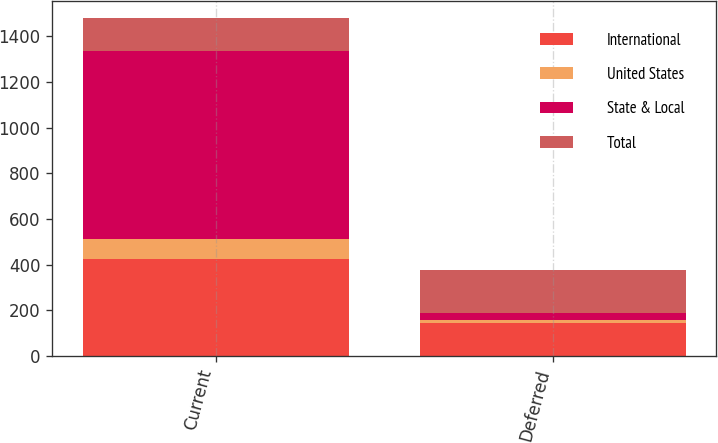<chart> <loc_0><loc_0><loc_500><loc_500><stacked_bar_chart><ecel><fcel>Current<fcel>Deferred<nl><fcel>International<fcel>426<fcel>145<nl><fcel>United States<fcel>84<fcel>11<nl><fcel>State & Local<fcel>826<fcel>32<nl><fcel>Total<fcel>145<fcel>188<nl></chart> 